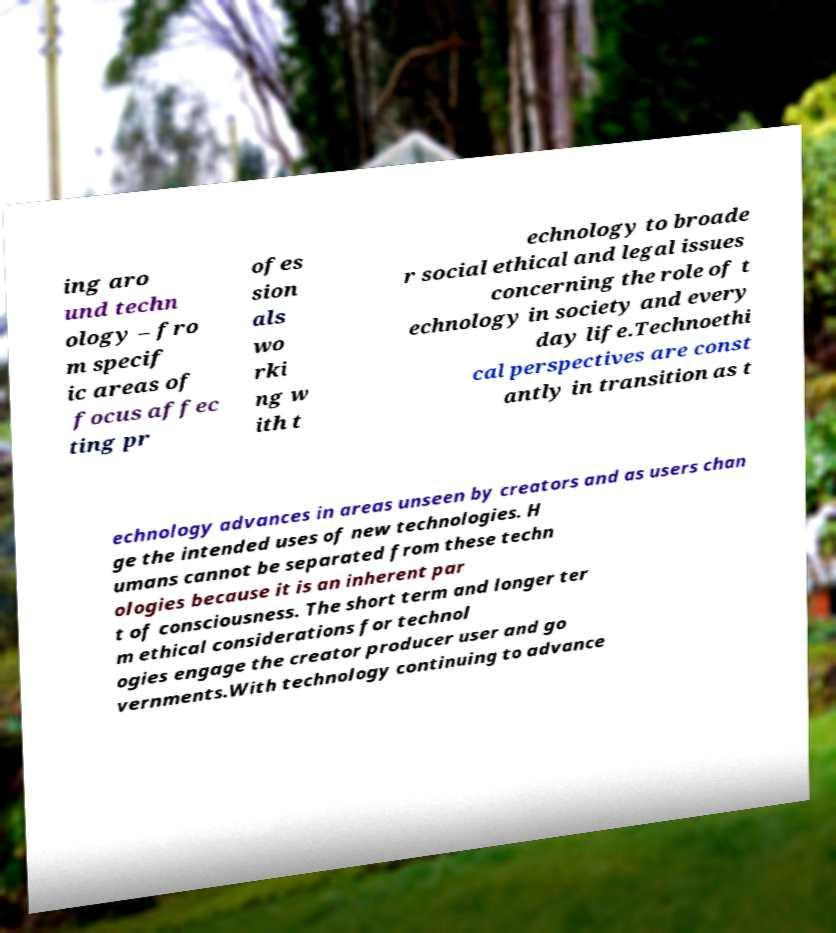There's text embedded in this image that I need extracted. Can you transcribe it verbatim? ing aro und techn ology – fro m specif ic areas of focus affec ting pr ofes sion als wo rki ng w ith t echnology to broade r social ethical and legal issues concerning the role of t echnology in society and every day life.Technoethi cal perspectives are const antly in transition as t echnology advances in areas unseen by creators and as users chan ge the intended uses of new technologies. H umans cannot be separated from these techn ologies because it is an inherent par t of consciousness. The short term and longer ter m ethical considerations for technol ogies engage the creator producer user and go vernments.With technology continuing to advance 